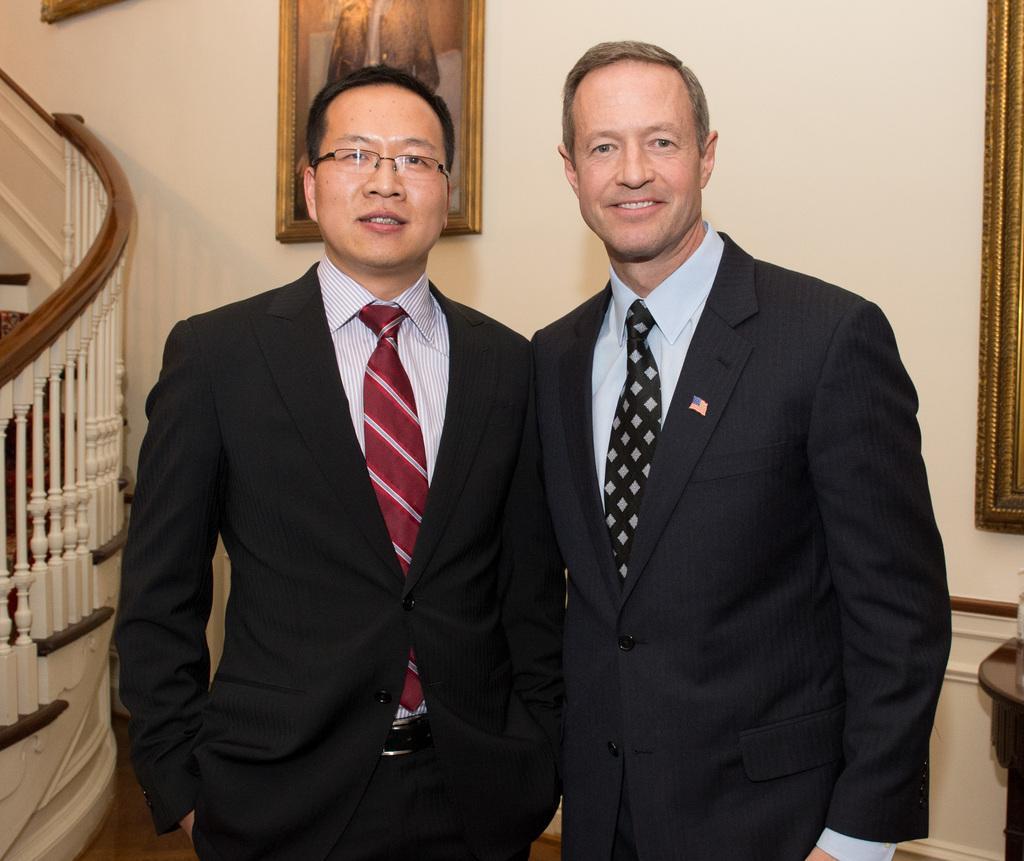Describe this image in one or two sentences. In the center of the image there are two people standing wearing suits. In the background of the image there is wall. There are photo frames. To the left side of the image there is stairs and staircase railing. 